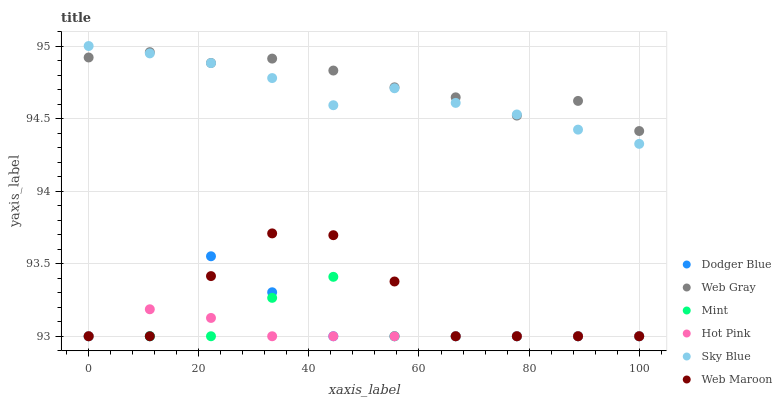Does Hot Pink have the minimum area under the curve?
Answer yes or no. Yes. Does Web Gray have the maximum area under the curve?
Answer yes or no. Yes. Does Web Maroon have the minimum area under the curve?
Answer yes or no. No. Does Web Maroon have the maximum area under the curve?
Answer yes or no. No. Is Hot Pink the smoothest?
Answer yes or no. Yes. Is Dodger Blue the roughest?
Answer yes or no. Yes. Is Web Maroon the smoothest?
Answer yes or no. No. Is Web Maroon the roughest?
Answer yes or no. No. Does Hot Pink have the lowest value?
Answer yes or no. Yes. Does Sky Blue have the lowest value?
Answer yes or no. No. Does Sky Blue have the highest value?
Answer yes or no. Yes. Does Web Maroon have the highest value?
Answer yes or no. No. Is Mint less than Sky Blue?
Answer yes or no. Yes. Is Web Gray greater than Mint?
Answer yes or no. Yes. Does Web Maroon intersect Mint?
Answer yes or no. Yes. Is Web Maroon less than Mint?
Answer yes or no. No. Is Web Maroon greater than Mint?
Answer yes or no. No. Does Mint intersect Sky Blue?
Answer yes or no. No. 